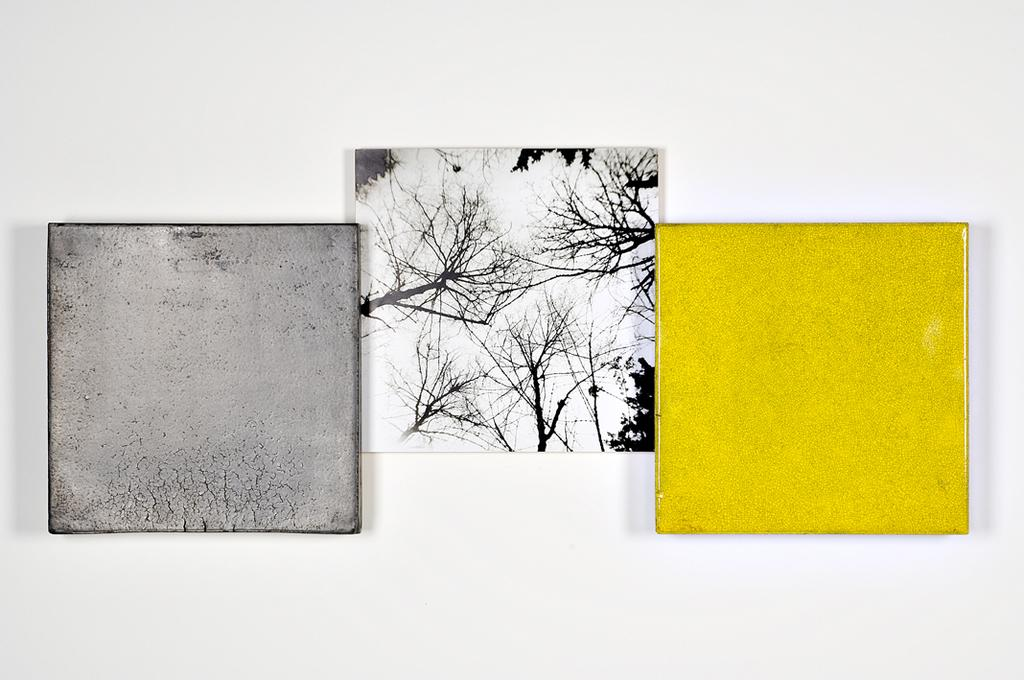What is hanging on the wall in the image? There are painting frames on the wall in the image. How many jellyfish can be seen swimming in the painting frames in the image? There are no jellyfish present in the image; the painting frames are empty or contain other subjects. 